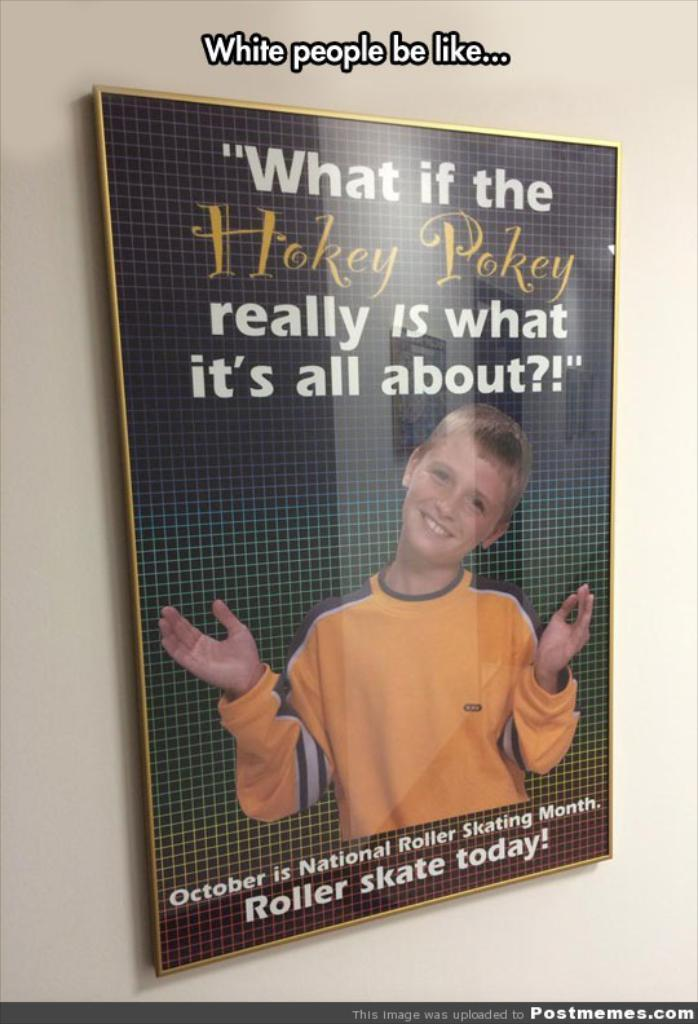<image>
Render a clear and concise summary of the photo. a book that has the words hokey pokey on it 